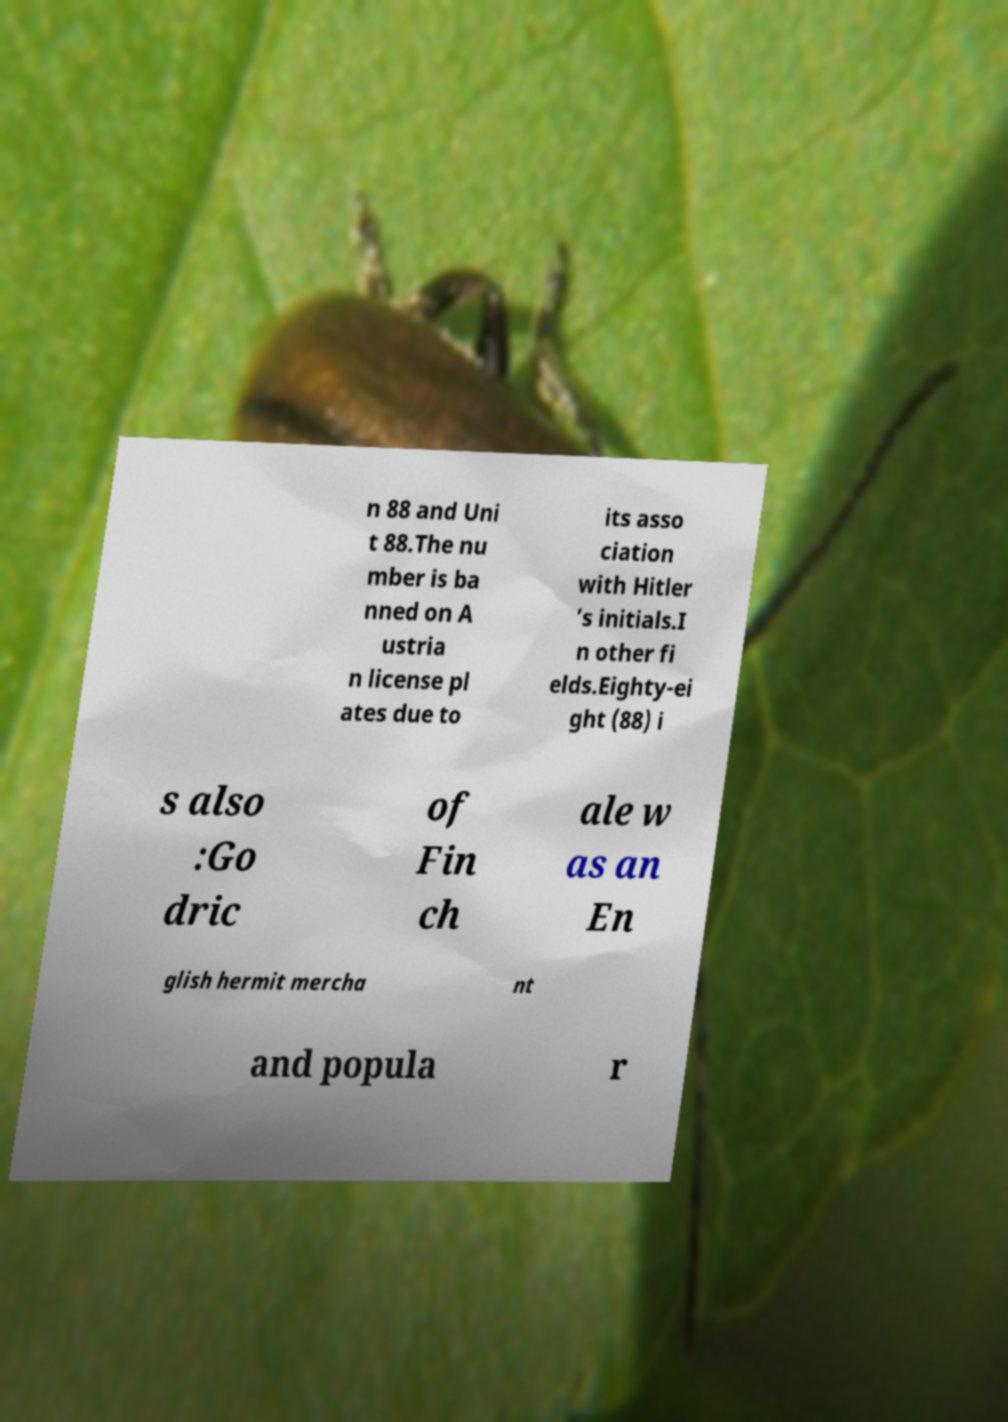There's text embedded in this image that I need extracted. Can you transcribe it verbatim? n 88 and Uni t 88.The nu mber is ba nned on A ustria n license pl ates due to its asso ciation with Hitler ’s initials.I n other fi elds.Eighty-ei ght (88) i s also :Go dric of Fin ch ale w as an En glish hermit mercha nt and popula r 